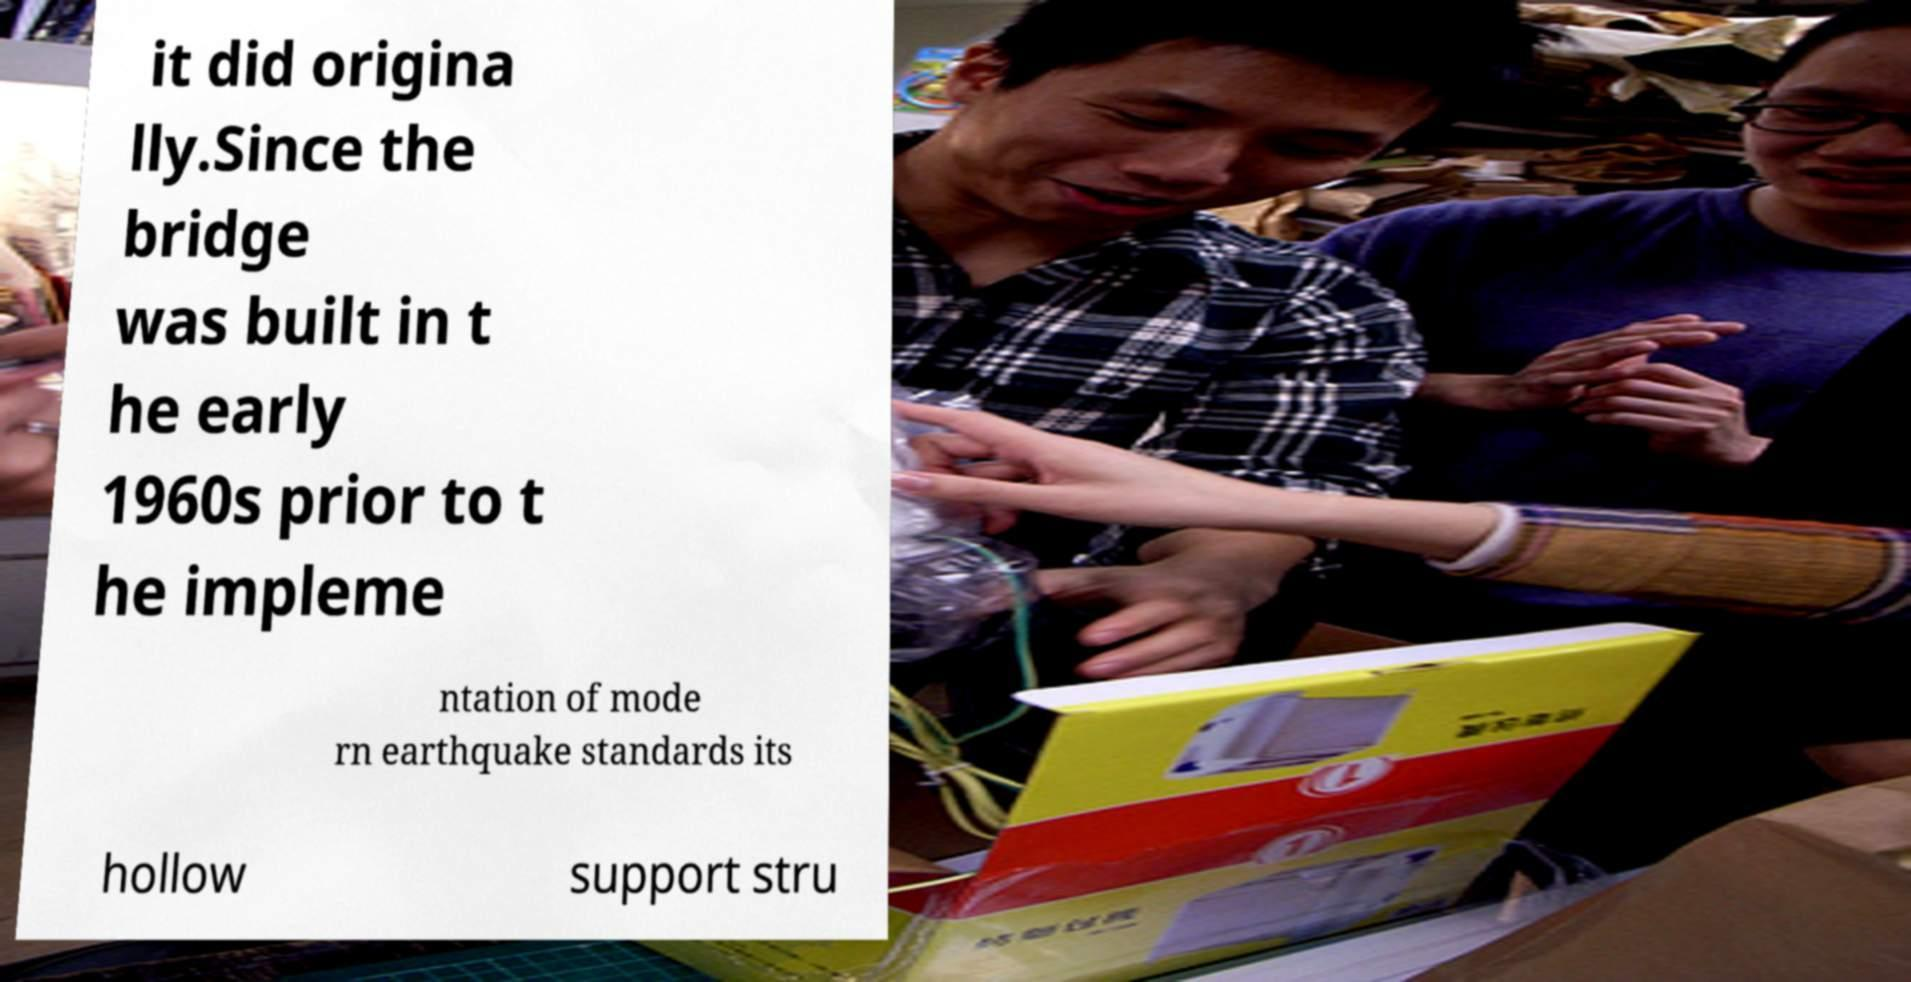There's text embedded in this image that I need extracted. Can you transcribe it verbatim? it did origina lly.Since the bridge was built in t he early 1960s prior to t he impleme ntation of mode rn earthquake standards its hollow support stru 